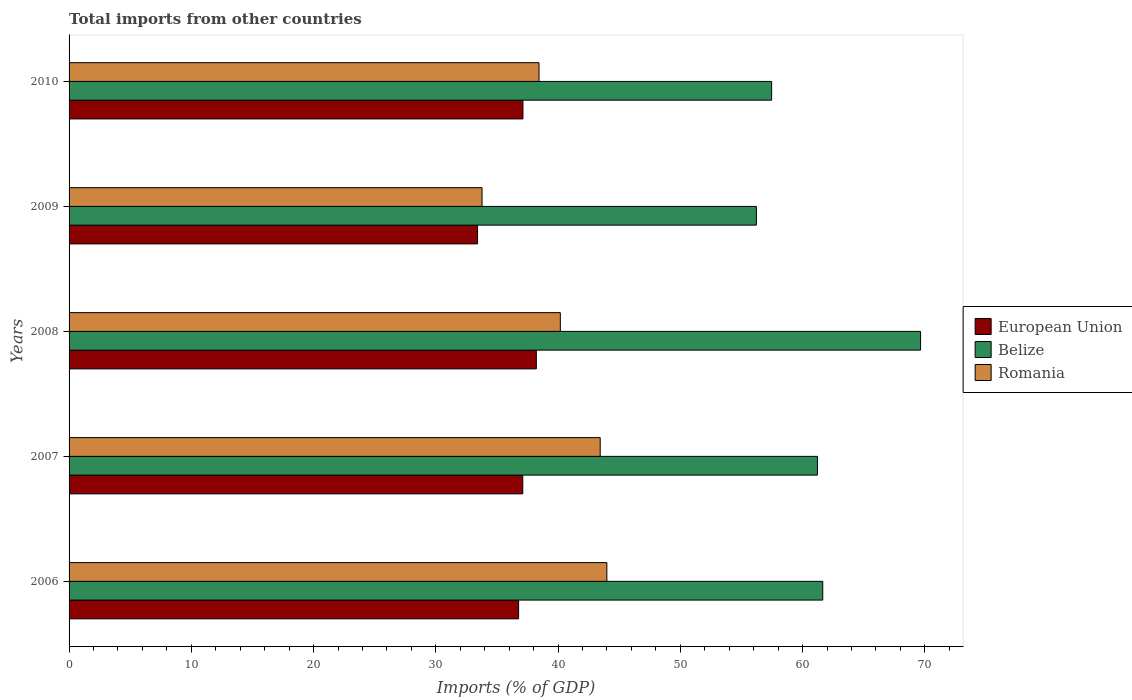How many different coloured bars are there?
Give a very brief answer. 3. How many groups of bars are there?
Your response must be concise. 5. Are the number of bars per tick equal to the number of legend labels?
Your response must be concise. Yes. Are the number of bars on each tick of the Y-axis equal?
Offer a very short reply. Yes. How many bars are there on the 3rd tick from the bottom?
Ensure brevity in your answer.  3. What is the label of the 4th group of bars from the top?
Make the answer very short. 2007. In how many cases, is the number of bars for a given year not equal to the number of legend labels?
Offer a terse response. 0. What is the total imports in Romania in 2010?
Provide a succinct answer. 38.44. Across all years, what is the maximum total imports in Romania?
Keep it short and to the point. 43.99. Across all years, what is the minimum total imports in Romania?
Make the answer very short. 33.78. In which year was the total imports in Belize maximum?
Give a very brief answer. 2008. In which year was the total imports in Belize minimum?
Provide a succinct answer. 2009. What is the total total imports in Belize in the graph?
Your answer should be very brief. 306.22. What is the difference between the total imports in Romania in 2006 and that in 2009?
Your answer should be compact. 10.21. What is the difference between the total imports in Belize in 2008 and the total imports in Romania in 2007?
Give a very brief answer. 26.21. What is the average total imports in Belize per year?
Your answer should be very brief. 61.24. In the year 2006, what is the difference between the total imports in Romania and total imports in European Union?
Your answer should be compact. 7.22. In how many years, is the total imports in Romania greater than 36 %?
Keep it short and to the point. 4. What is the ratio of the total imports in European Union in 2007 to that in 2008?
Ensure brevity in your answer.  0.97. Is the total imports in Belize in 2006 less than that in 2010?
Keep it short and to the point. No. Is the difference between the total imports in Romania in 2006 and 2008 greater than the difference between the total imports in European Union in 2006 and 2008?
Keep it short and to the point. Yes. What is the difference between the highest and the second highest total imports in European Union?
Provide a succinct answer. 1.1. What is the difference between the highest and the lowest total imports in European Union?
Offer a terse response. 4.81. Is the sum of the total imports in European Union in 2009 and 2010 greater than the maximum total imports in Belize across all years?
Provide a short and direct response. Yes. What does the 2nd bar from the top in 2010 represents?
Offer a very short reply. Belize. What does the 1st bar from the bottom in 2009 represents?
Offer a very short reply. European Union. Is it the case that in every year, the sum of the total imports in Belize and total imports in European Union is greater than the total imports in Romania?
Make the answer very short. Yes. How many bars are there?
Keep it short and to the point. 15. Are all the bars in the graph horizontal?
Provide a succinct answer. Yes. Are the values on the major ticks of X-axis written in scientific E-notation?
Your response must be concise. No. Does the graph contain grids?
Provide a succinct answer. No. How many legend labels are there?
Ensure brevity in your answer.  3. What is the title of the graph?
Make the answer very short. Total imports from other countries. What is the label or title of the X-axis?
Keep it short and to the point. Imports (% of GDP). What is the Imports (% of GDP) of European Union in 2006?
Offer a very short reply. 36.77. What is the Imports (% of GDP) of Belize in 2006?
Your answer should be very brief. 61.65. What is the Imports (% of GDP) of Romania in 2006?
Offer a very short reply. 43.99. What is the Imports (% of GDP) in European Union in 2007?
Give a very brief answer. 37.11. What is the Imports (% of GDP) in Belize in 2007?
Offer a very short reply. 61.22. What is the Imports (% of GDP) of Romania in 2007?
Give a very brief answer. 43.45. What is the Imports (% of GDP) in European Union in 2008?
Make the answer very short. 38.22. What is the Imports (% of GDP) in Belize in 2008?
Your answer should be compact. 69.65. What is the Imports (% of GDP) of Romania in 2008?
Ensure brevity in your answer.  40.19. What is the Imports (% of GDP) in European Union in 2009?
Your answer should be compact. 33.41. What is the Imports (% of GDP) in Belize in 2009?
Your answer should be very brief. 56.22. What is the Imports (% of GDP) in Romania in 2009?
Offer a terse response. 33.78. What is the Imports (% of GDP) of European Union in 2010?
Offer a terse response. 37.13. What is the Imports (% of GDP) of Belize in 2010?
Your answer should be very brief. 57.47. What is the Imports (% of GDP) in Romania in 2010?
Keep it short and to the point. 38.44. Across all years, what is the maximum Imports (% of GDP) of European Union?
Ensure brevity in your answer.  38.22. Across all years, what is the maximum Imports (% of GDP) in Belize?
Give a very brief answer. 69.65. Across all years, what is the maximum Imports (% of GDP) in Romania?
Offer a terse response. 43.99. Across all years, what is the minimum Imports (% of GDP) in European Union?
Keep it short and to the point. 33.41. Across all years, what is the minimum Imports (% of GDP) in Belize?
Provide a succinct answer. 56.22. Across all years, what is the minimum Imports (% of GDP) of Romania?
Keep it short and to the point. 33.78. What is the total Imports (% of GDP) in European Union in the graph?
Give a very brief answer. 182.65. What is the total Imports (% of GDP) of Belize in the graph?
Your response must be concise. 306.22. What is the total Imports (% of GDP) in Romania in the graph?
Provide a short and direct response. 199.85. What is the difference between the Imports (% of GDP) of European Union in 2006 and that in 2007?
Give a very brief answer. -0.34. What is the difference between the Imports (% of GDP) of Belize in 2006 and that in 2007?
Give a very brief answer. 0.43. What is the difference between the Imports (% of GDP) of Romania in 2006 and that in 2007?
Give a very brief answer. 0.55. What is the difference between the Imports (% of GDP) of European Union in 2006 and that in 2008?
Provide a short and direct response. -1.45. What is the difference between the Imports (% of GDP) in Belize in 2006 and that in 2008?
Your response must be concise. -8. What is the difference between the Imports (% of GDP) in Romania in 2006 and that in 2008?
Give a very brief answer. 3.81. What is the difference between the Imports (% of GDP) in European Union in 2006 and that in 2009?
Your answer should be compact. 3.36. What is the difference between the Imports (% of GDP) of Belize in 2006 and that in 2009?
Provide a succinct answer. 5.43. What is the difference between the Imports (% of GDP) in Romania in 2006 and that in 2009?
Keep it short and to the point. 10.21. What is the difference between the Imports (% of GDP) in European Union in 2006 and that in 2010?
Give a very brief answer. -0.35. What is the difference between the Imports (% of GDP) of Belize in 2006 and that in 2010?
Offer a very short reply. 4.18. What is the difference between the Imports (% of GDP) in Romania in 2006 and that in 2010?
Give a very brief answer. 5.55. What is the difference between the Imports (% of GDP) of European Union in 2007 and that in 2008?
Your answer should be very brief. -1.11. What is the difference between the Imports (% of GDP) of Belize in 2007 and that in 2008?
Provide a short and direct response. -8.44. What is the difference between the Imports (% of GDP) of Romania in 2007 and that in 2008?
Keep it short and to the point. 3.26. What is the difference between the Imports (% of GDP) of European Union in 2007 and that in 2009?
Your answer should be compact. 3.7. What is the difference between the Imports (% of GDP) of Belize in 2007 and that in 2009?
Offer a terse response. 4.99. What is the difference between the Imports (% of GDP) in Romania in 2007 and that in 2009?
Your answer should be compact. 9.67. What is the difference between the Imports (% of GDP) of European Union in 2007 and that in 2010?
Keep it short and to the point. -0.01. What is the difference between the Imports (% of GDP) of Belize in 2007 and that in 2010?
Make the answer very short. 3.75. What is the difference between the Imports (% of GDP) in Romania in 2007 and that in 2010?
Offer a very short reply. 5. What is the difference between the Imports (% of GDP) of European Union in 2008 and that in 2009?
Keep it short and to the point. 4.81. What is the difference between the Imports (% of GDP) in Belize in 2008 and that in 2009?
Give a very brief answer. 13.43. What is the difference between the Imports (% of GDP) in Romania in 2008 and that in 2009?
Ensure brevity in your answer.  6.4. What is the difference between the Imports (% of GDP) in European Union in 2008 and that in 2010?
Your answer should be very brief. 1.1. What is the difference between the Imports (% of GDP) of Belize in 2008 and that in 2010?
Offer a very short reply. 12.18. What is the difference between the Imports (% of GDP) in Romania in 2008 and that in 2010?
Provide a short and direct response. 1.74. What is the difference between the Imports (% of GDP) in European Union in 2009 and that in 2010?
Offer a terse response. -3.71. What is the difference between the Imports (% of GDP) of Belize in 2009 and that in 2010?
Offer a very short reply. -1.25. What is the difference between the Imports (% of GDP) in Romania in 2009 and that in 2010?
Offer a very short reply. -4.66. What is the difference between the Imports (% of GDP) of European Union in 2006 and the Imports (% of GDP) of Belize in 2007?
Provide a short and direct response. -24.44. What is the difference between the Imports (% of GDP) of European Union in 2006 and the Imports (% of GDP) of Romania in 2007?
Offer a terse response. -6.67. What is the difference between the Imports (% of GDP) of Belize in 2006 and the Imports (% of GDP) of Romania in 2007?
Offer a terse response. 18.2. What is the difference between the Imports (% of GDP) of European Union in 2006 and the Imports (% of GDP) of Belize in 2008?
Your response must be concise. -32.88. What is the difference between the Imports (% of GDP) in European Union in 2006 and the Imports (% of GDP) in Romania in 2008?
Give a very brief answer. -3.41. What is the difference between the Imports (% of GDP) in Belize in 2006 and the Imports (% of GDP) in Romania in 2008?
Your response must be concise. 21.47. What is the difference between the Imports (% of GDP) of European Union in 2006 and the Imports (% of GDP) of Belize in 2009?
Your answer should be compact. -19.45. What is the difference between the Imports (% of GDP) in European Union in 2006 and the Imports (% of GDP) in Romania in 2009?
Provide a short and direct response. 2.99. What is the difference between the Imports (% of GDP) of Belize in 2006 and the Imports (% of GDP) of Romania in 2009?
Give a very brief answer. 27.87. What is the difference between the Imports (% of GDP) of European Union in 2006 and the Imports (% of GDP) of Belize in 2010?
Provide a short and direct response. -20.7. What is the difference between the Imports (% of GDP) of European Union in 2006 and the Imports (% of GDP) of Romania in 2010?
Provide a short and direct response. -1.67. What is the difference between the Imports (% of GDP) of Belize in 2006 and the Imports (% of GDP) of Romania in 2010?
Give a very brief answer. 23.21. What is the difference between the Imports (% of GDP) in European Union in 2007 and the Imports (% of GDP) in Belize in 2008?
Provide a succinct answer. -32.54. What is the difference between the Imports (% of GDP) of European Union in 2007 and the Imports (% of GDP) of Romania in 2008?
Your answer should be compact. -3.07. What is the difference between the Imports (% of GDP) in Belize in 2007 and the Imports (% of GDP) in Romania in 2008?
Your answer should be very brief. 21.03. What is the difference between the Imports (% of GDP) of European Union in 2007 and the Imports (% of GDP) of Belize in 2009?
Keep it short and to the point. -19.11. What is the difference between the Imports (% of GDP) of European Union in 2007 and the Imports (% of GDP) of Romania in 2009?
Your answer should be compact. 3.33. What is the difference between the Imports (% of GDP) in Belize in 2007 and the Imports (% of GDP) in Romania in 2009?
Your answer should be very brief. 27.44. What is the difference between the Imports (% of GDP) of European Union in 2007 and the Imports (% of GDP) of Belize in 2010?
Offer a very short reply. -20.36. What is the difference between the Imports (% of GDP) in European Union in 2007 and the Imports (% of GDP) in Romania in 2010?
Offer a terse response. -1.33. What is the difference between the Imports (% of GDP) in Belize in 2007 and the Imports (% of GDP) in Romania in 2010?
Offer a very short reply. 22.77. What is the difference between the Imports (% of GDP) in European Union in 2008 and the Imports (% of GDP) in Belize in 2009?
Give a very brief answer. -18. What is the difference between the Imports (% of GDP) in European Union in 2008 and the Imports (% of GDP) in Romania in 2009?
Make the answer very short. 4.44. What is the difference between the Imports (% of GDP) of Belize in 2008 and the Imports (% of GDP) of Romania in 2009?
Ensure brevity in your answer.  35.87. What is the difference between the Imports (% of GDP) in European Union in 2008 and the Imports (% of GDP) in Belize in 2010?
Your answer should be compact. -19.25. What is the difference between the Imports (% of GDP) of European Union in 2008 and the Imports (% of GDP) of Romania in 2010?
Provide a short and direct response. -0.22. What is the difference between the Imports (% of GDP) of Belize in 2008 and the Imports (% of GDP) of Romania in 2010?
Make the answer very short. 31.21. What is the difference between the Imports (% of GDP) of European Union in 2009 and the Imports (% of GDP) of Belize in 2010?
Ensure brevity in your answer.  -24.06. What is the difference between the Imports (% of GDP) of European Union in 2009 and the Imports (% of GDP) of Romania in 2010?
Offer a very short reply. -5.03. What is the difference between the Imports (% of GDP) in Belize in 2009 and the Imports (% of GDP) in Romania in 2010?
Your answer should be compact. 17.78. What is the average Imports (% of GDP) of European Union per year?
Provide a short and direct response. 36.53. What is the average Imports (% of GDP) of Belize per year?
Offer a terse response. 61.24. What is the average Imports (% of GDP) of Romania per year?
Your response must be concise. 39.97. In the year 2006, what is the difference between the Imports (% of GDP) of European Union and Imports (% of GDP) of Belize?
Ensure brevity in your answer.  -24.88. In the year 2006, what is the difference between the Imports (% of GDP) of European Union and Imports (% of GDP) of Romania?
Keep it short and to the point. -7.22. In the year 2006, what is the difference between the Imports (% of GDP) in Belize and Imports (% of GDP) in Romania?
Offer a very short reply. 17.66. In the year 2007, what is the difference between the Imports (% of GDP) in European Union and Imports (% of GDP) in Belize?
Make the answer very short. -24.1. In the year 2007, what is the difference between the Imports (% of GDP) of European Union and Imports (% of GDP) of Romania?
Ensure brevity in your answer.  -6.33. In the year 2007, what is the difference between the Imports (% of GDP) in Belize and Imports (% of GDP) in Romania?
Provide a short and direct response. 17.77. In the year 2008, what is the difference between the Imports (% of GDP) of European Union and Imports (% of GDP) of Belize?
Your response must be concise. -31.43. In the year 2008, what is the difference between the Imports (% of GDP) in European Union and Imports (% of GDP) in Romania?
Give a very brief answer. -1.96. In the year 2008, what is the difference between the Imports (% of GDP) in Belize and Imports (% of GDP) in Romania?
Provide a short and direct response. 29.47. In the year 2009, what is the difference between the Imports (% of GDP) in European Union and Imports (% of GDP) in Belize?
Ensure brevity in your answer.  -22.81. In the year 2009, what is the difference between the Imports (% of GDP) in European Union and Imports (% of GDP) in Romania?
Offer a terse response. -0.37. In the year 2009, what is the difference between the Imports (% of GDP) in Belize and Imports (% of GDP) in Romania?
Your answer should be very brief. 22.44. In the year 2010, what is the difference between the Imports (% of GDP) of European Union and Imports (% of GDP) of Belize?
Provide a succinct answer. -20.34. In the year 2010, what is the difference between the Imports (% of GDP) in European Union and Imports (% of GDP) in Romania?
Provide a short and direct response. -1.32. In the year 2010, what is the difference between the Imports (% of GDP) of Belize and Imports (% of GDP) of Romania?
Provide a short and direct response. 19.03. What is the ratio of the Imports (% of GDP) in European Union in 2006 to that in 2007?
Give a very brief answer. 0.99. What is the ratio of the Imports (% of GDP) of Belize in 2006 to that in 2007?
Ensure brevity in your answer.  1.01. What is the ratio of the Imports (% of GDP) in Romania in 2006 to that in 2007?
Provide a succinct answer. 1.01. What is the ratio of the Imports (% of GDP) of European Union in 2006 to that in 2008?
Provide a succinct answer. 0.96. What is the ratio of the Imports (% of GDP) in Belize in 2006 to that in 2008?
Keep it short and to the point. 0.89. What is the ratio of the Imports (% of GDP) in Romania in 2006 to that in 2008?
Ensure brevity in your answer.  1.09. What is the ratio of the Imports (% of GDP) of European Union in 2006 to that in 2009?
Provide a succinct answer. 1.1. What is the ratio of the Imports (% of GDP) of Belize in 2006 to that in 2009?
Your answer should be compact. 1.1. What is the ratio of the Imports (% of GDP) of Romania in 2006 to that in 2009?
Provide a succinct answer. 1.3. What is the ratio of the Imports (% of GDP) in Belize in 2006 to that in 2010?
Offer a very short reply. 1.07. What is the ratio of the Imports (% of GDP) in Romania in 2006 to that in 2010?
Offer a very short reply. 1.14. What is the ratio of the Imports (% of GDP) in Belize in 2007 to that in 2008?
Your response must be concise. 0.88. What is the ratio of the Imports (% of GDP) in Romania in 2007 to that in 2008?
Give a very brief answer. 1.08. What is the ratio of the Imports (% of GDP) in European Union in 2007 to that in 2009?
Offer a very short reply. 1.11. What is the ratio of the Imports (% of GDP) of Belize in 2007 to that in 2009?
Give a very brief answer. 1.09. What is the ratio of the Imports (% of GDP) in Romania in 2007 to that in 2009?
Offer a terse response. 1.29. What is the ratio of the Imports (% of GDP) in Belize in 2007 to that in 2010?
Ensure brevity in your answer.  1.07. What is the ratio of the Imports (% of GDP) of Romania in 2007 to that in 2010?
Offer a very short reply. 1.13. What is the ratio of the Imports (% of GDP) in European Union in 2008 to that in 2009?
Provide a succinct answer. 1.14. What is the ratio of the Imports (% of GDP) of Belize in 2008 to that in 2009?
Your response must be concise. 1.24. What is the ratio of the Imports (% of GDP) of Romania in 2008 to that in 2009?
Give a very brief answer. 1.19. What is the ratio of the Imports (% of GDP) in European Union in 2008 to that in 2010?
Make the answer very short. 1.03. What is the ratio of the Imports (% of GDP) in Belize in 2008 to that in 2010?
Offer a terse response. 1.21. What is the ratio of the Imports (% of GDP) of Romania in 2008 to that in 2010?
Give a very brief answer. 1.05. What is the ratio of the Imports (% of GDP) in European Union in 2009 to that in 2010?
Provide a succinct answer. 0.9. What is the ratio of the Imports (% of GDP) of Belize in 2009 to that in 2010?
Your response must be concise. 0.98. What is the ratio of the Imports (% of GDP) of Romania in 2009 to that in 2010?
Ensure brevity in your answer.  0.88. What is the difference between the highest and the second highest Imports (% of GDP) of European Union?
Ensure brevity in your answer.  1.1. What is the difference between the highest and the second highest Imports (% of GDP) in Belize?
Keep it short and to the point. 8. What is the difference between the highest and the second highest Imports (% of GDP) in Romania?
Provide a short and direct response. 0.55. What is the difference between the highest and the lowest Imports (% of GDP) in European Union?
Provide a short and direct response. 4.81. What is the difference between the highest and the lowest Imports (% of GDP) in Belize?
Give a very brief answer. 13.43. What is the difference between the highest and the lowest Imports (% of GDP) of Romania?
Provide a succinct answer. 10.21. 